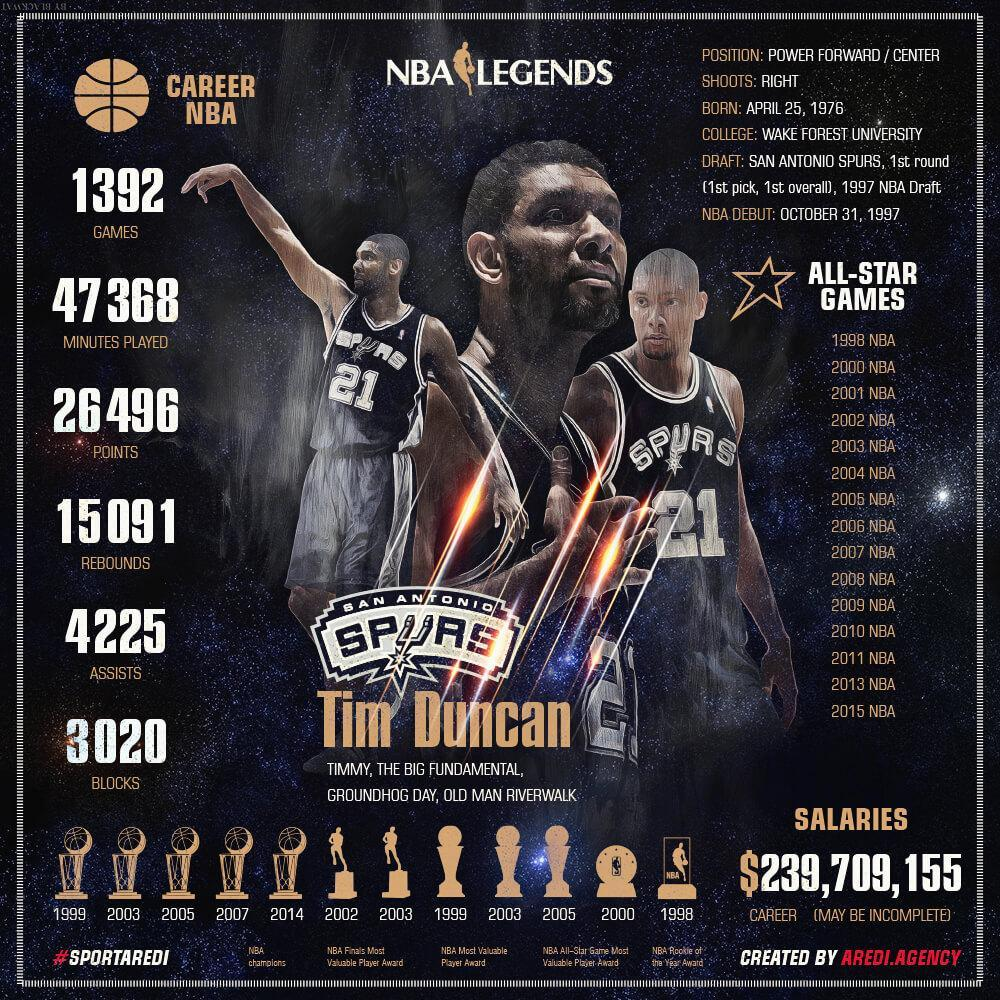How many times did he win NBA Most valuable award
Answer the question with a short phrase. 2 How many NBA champions did he win 5 When did he win NBA Finals most valuable player awards 2002 2003 What did Tim Duncan win in 1998 NBA Rookie of the year award How many points has he scored 26496 What is the number on the T Shirt 21 